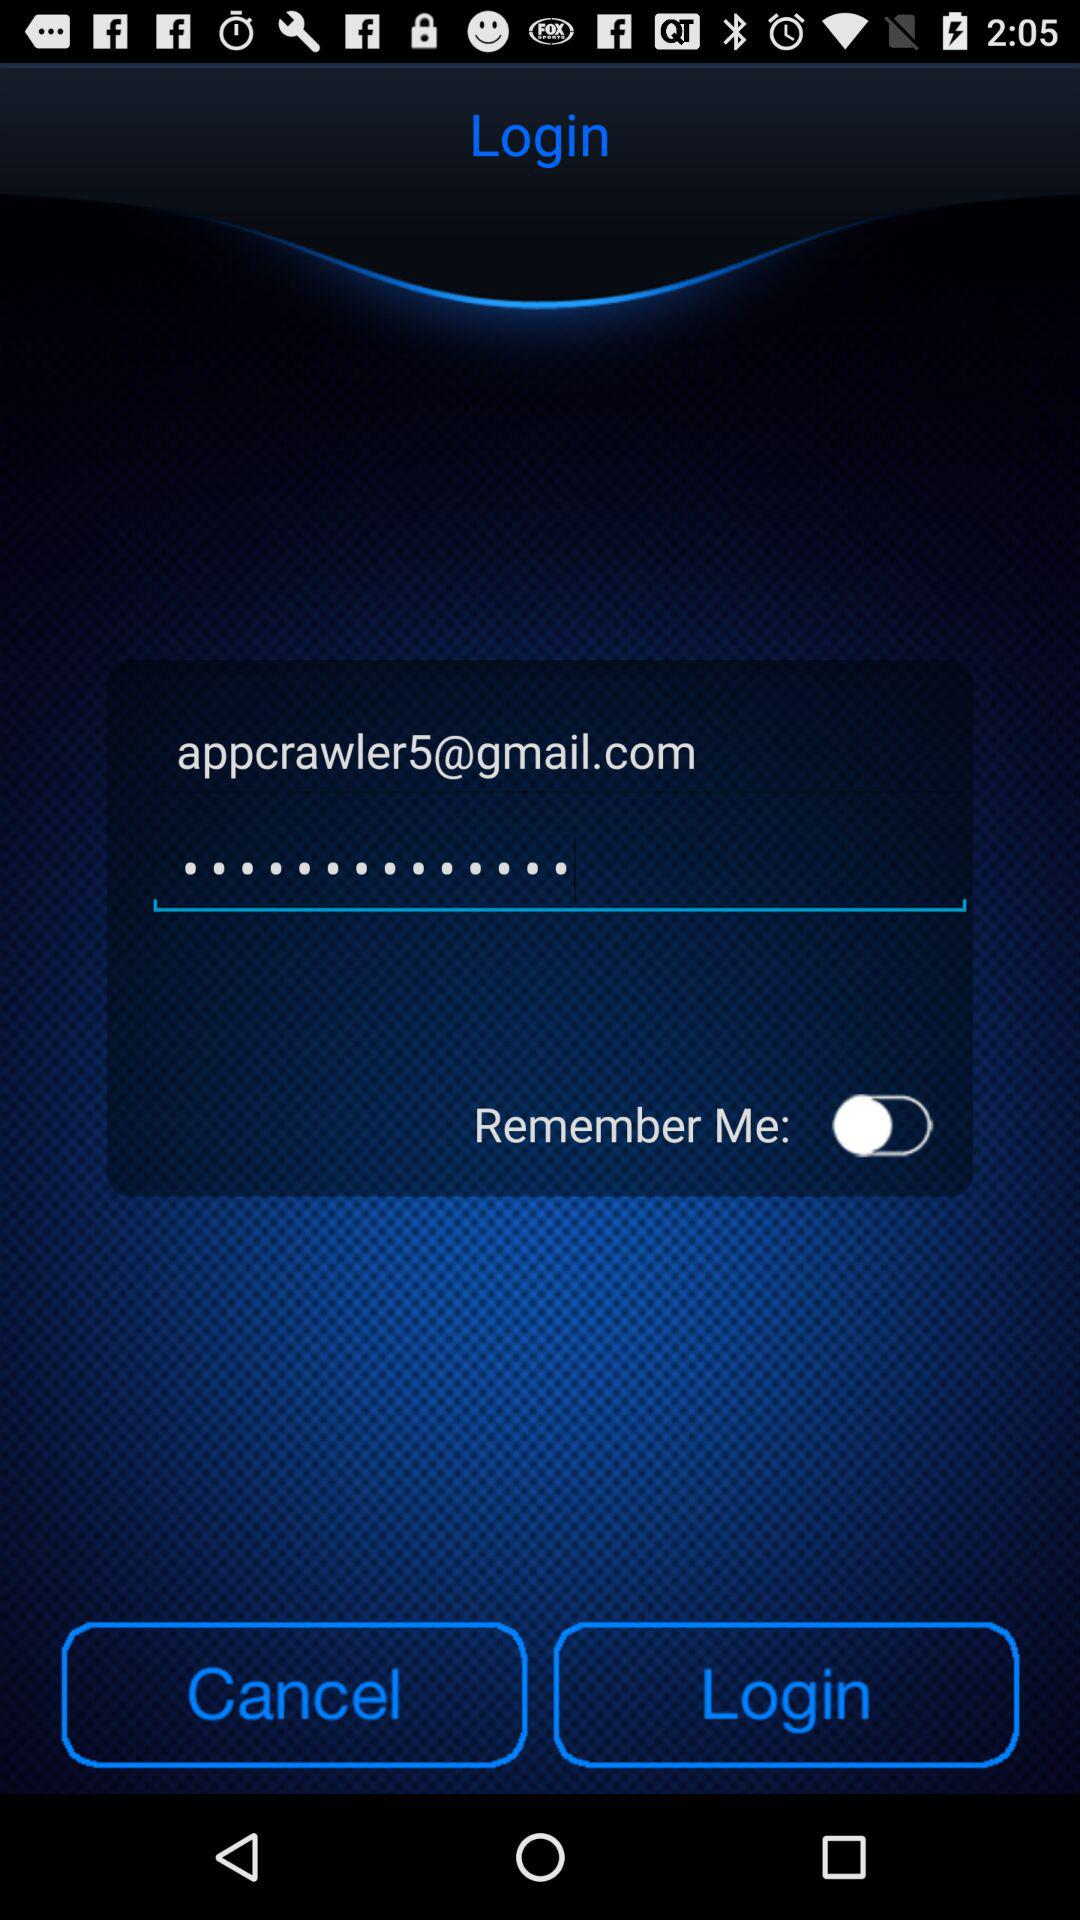What is the status of "Remember Me"? The status is "off". 